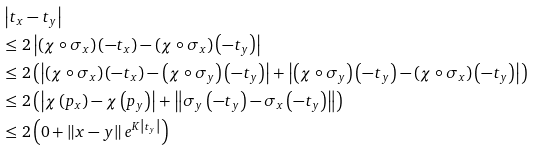Convert formula to latex. <formula><loc_0><loc_0><loc_500><loc_500>& \left | t _ { x } - t _ { y } \right | \\ & \leq 2 \left | \left ( \chi \circ \sigma _ { x } \right ) \left ( - t _ { x } \right ) - \left ( \chi \circ \sigma _ { x } \right ) \left ( - t _ { y } \right ) \right | \\ & \leq 2 \left ( \left | \left ( \chi \circ \sigma _ { x } \right ) \left ( - t _ { x } \right ) - \left ( \chi \circ \sigma _ { y } \right ) \left ( - t _ { y } \right ) \right | + \left | \left ( \chi \circ \sigma _ { y } \right ) \left ( - t _ { y } \right ) - \left ( \chi \circ \sigma _ { x } \right ) \left ( - t _ { y } \right ) \right | \right ) \\ & \leq 2 \left ( \left | \chi \left ( p _ { x } \right ) - \chi \left ( p _ { y } \right ) \right | + \left \| \sigma _ { y } \left ( - t _ { y } \right ) - \sigma _ { x } \left ( - t _ { y } \right ) \right \| \right ) \\ & \leq 2 \left ( 0 + \left \| x - y \right \| e ^ { K \left | t _ { y } \right | } \right )</formula> 